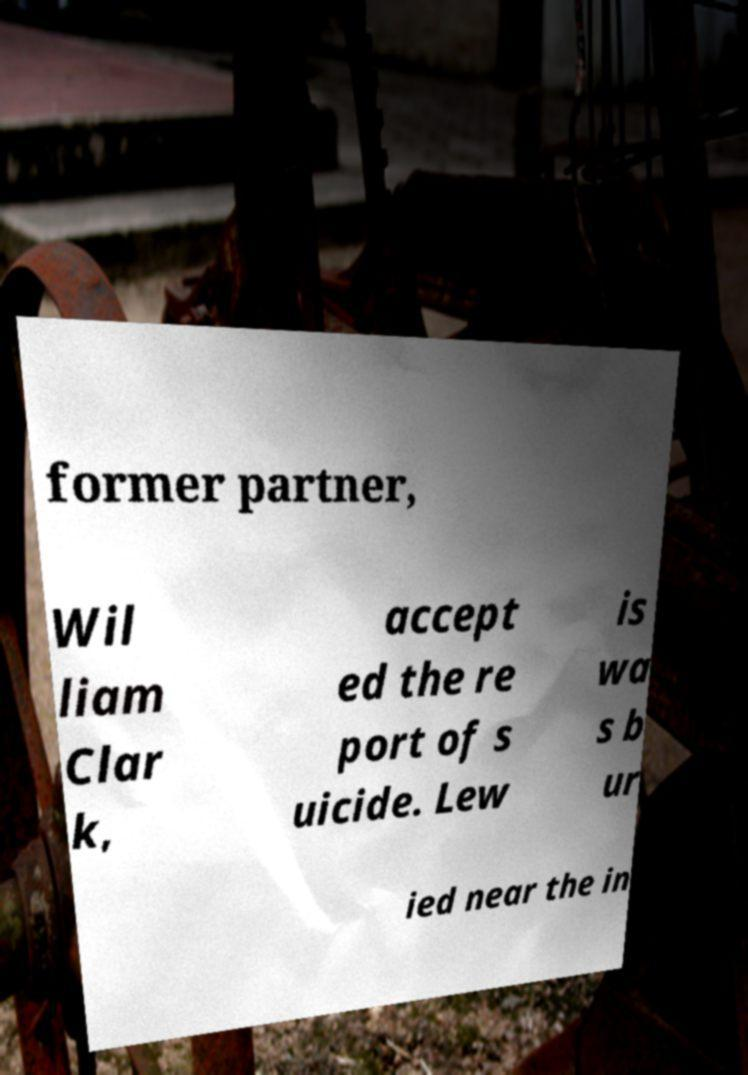For documentation purposes, I need the text within this image transcribed. Could you provide that? former partner, Wil liam Clar k, accept ed the re port of s uicide. Lew is wa s b ur ied near the in 